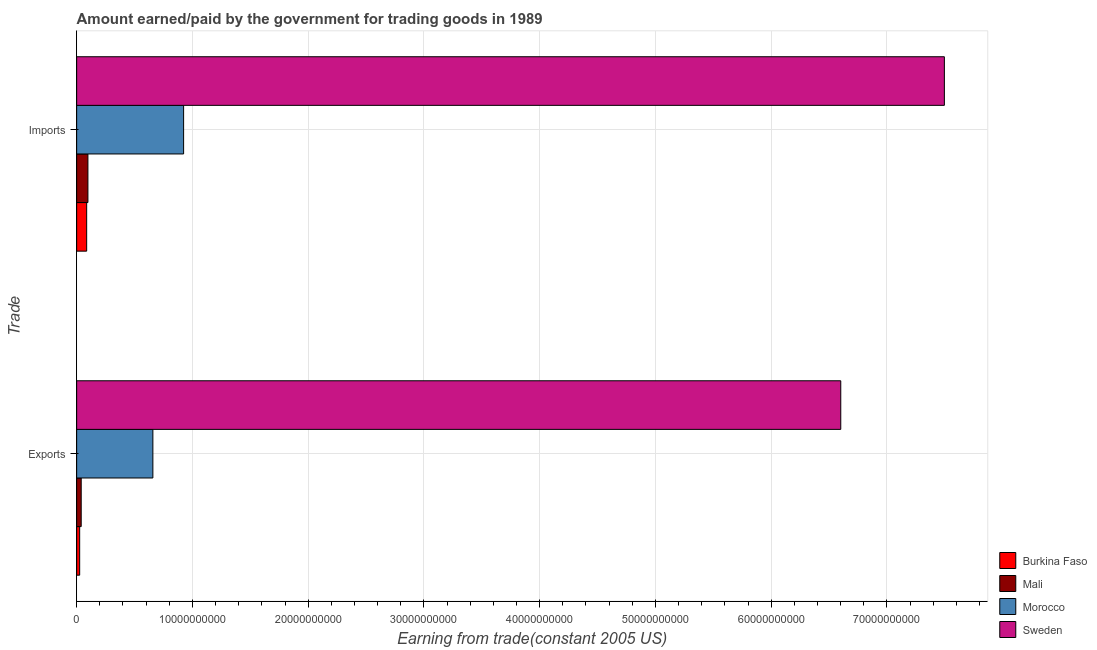How many different coloured bars are there?
Keep it short and to the point. 4. How many groups of bars are there?
Give a very brief answer. 2. Are the number of bars per tick equal to the number of legend labels?
Make the answer very short. Yes. Are the number of bars on each tick of the Y-axis equal?
Provide a short and direct response. Yes. How many bars are there on the 1st tick from the top?
Give a very brief answer. 4. How many bars are there on the 1st tick from the bottom?
Keep it short and to the point. 4. What is the label of the 2nd group of bars from the top?
Your answer should be compact. Exports. What is the amount paid for imports in Burkina Faso?
Make the answer very short. 8.65e+08. Across all countries, what is the maximum amount earned from exports?
Your response must be concise. 6.60e+1. Across all countries, what is the minimum amount paid for imports?
Offer a terse response. 8.65e+08. In which country was the amount paid for imports maximum?
Give a very brief answer. Sweden. In which country was the amount earned from exports minimum?
Give a very brief answer. Burkina Faso. What is the total amount paid for imports in the graph?
Make the answer very short. 8.60e+1. What is the difference between the amount earned from exports in Sweden and that in Morocco?
Ensure brevity in your answer.  5.94e+1. What is the difference between the amount earned from exports in Mali and the amount paid for imports in Morocco?
Make the answer very short. -8.85e+09. What is the average amount earned from exports per country?
Your answer should be very brief. 1.83e+1. What is the difference between the amount paid for imports and amount earned from exports in Morocco?
Provide a succinct answer. 2.66e+09. What is the ratio of the amount paid for imports in Mali to that in Morocco?
Make the answer very short. 0.11. In how many countries, is the amount paid for imports greater than the average amount paid for imports taken over all countries?
Your response must be concise. 1. What does the 2nd bar from the top in Exports represents?
Your response must be concise. Morocco. What does the 1st bar from the bottom in Exports represents?
Your response must be concise. Burkina Faso. How many bars are there?
Offer a terse response. 8. Are all the bars in the graph horizontal?
Offer a terse response. Yes. What is the difference between two consecutive major ticks on the X-axis?
Offer a terse response. 1.00e+1. Where does the legend appear in the graph?
Your answer should be very brief. Bottom right. How are the legend labels stacked?
Provide a short and direct response. Vertical. What is the title of the graph?
Provide a succinct answer. Amount earned/paid by the government for trading goods in 1989. Does "Vietnam" appear as one of the legend labels in the graph?
Make the answer very short. No. What is the label or title of the X-axis?
Provide a succinct answer. Earning from trade(constant 2005 US). What is the label or title of the Y-axis?
Make the answer very short. Trade. What is the Earning from trade(constant 2005 US) of Burkina Faso in Exports?
Provide a succinct answer. 2.60e+08. What is the Earning from trade(constant 2005 US) of Mali in Exports?
Your response must be concise. 3.92e+08. What is the Earning from trade(constant 2005 US) in Morocco in Exports?
Your answer should be very brief. 6.59e+09. What is the Earning from trade(constant 2005 US) in Sweden in Exports?
Offer a very short reply. 6.60e+1. What is the Earning from trade(constant 2005 US) of Burkina Faso in Imports?
Your response must be concise. 8.65e+08. What is the Earning from trade(constant 2005 US) of Mali in Imports?
Offer a terse response. 9.73e+08. What is the Earning from trade(constant 2005 US) of Morocco in Imports?
Give a very brief answer. 9.24e+09. What is the Earning from trade(constant 2005 US) in Sweden in Imports?
Offer a terse response. 7.50e+1. Across all Trade, what is the maximum Earning from trade(constant 2005 US) of Burkina Faso?
Offer a terse response. 8.65e+08. Across all Trade, what is the maximum Earning from trade(constant 2005 US) in Mali?
Your response must be concise. 9.73e+08. Across all Trade, what is the maximum Earning from trade(constant 2005 US) of Morocco?
Your answer should be very brief. 9.24e+09. Across all Trade, what is the maximum Earning from trade(constant 2005 US) of Sweden?
Your response must be concise. 7.50e+1. Across all Trade, what is the minimum Earning from trade(constant 2005 US) of Burkina Faso?
Offer a very short reply. 2.60e+08. Across all Trade, what is the minimum Earning from trade(constant 2005 US) of Mali?
Give a very brief answer. 3.92e+08. Across all Trade, what is the minimum Earning from trade(constant 2005 US) of Morocco?
Provide a short and direct response. 6.59e+09. Across all Trade, what is the minimum Earning from trade(constant 2005 US) in Sweden?
Your answer should be very brief. 6.60e+1. What is the total Earning from trade(constant 2005 US) of Burkina Faso in the graph?
Ensure brevity in your answer.  1.12e+09. What is the total Earning from trade(constant 2005 US) of Mali in the graph?
Provide a succinct answer. 1.36e+09. What is the total Earning from trade(constant 2005 US) in Morocco in the graph?
Your response must be concise. 1.58e+1. What is the total Earning from trade(constant 2005 US) of Sweden in the graph?
Give a very brief answer. 1.41e+11. What is the difference between the Earning from trade(constant 2005 US) in Burkina Faso in Exports and that in Imports?
Your answer should be very brief. -6.05e+08. What is the difference between the Earning from trade(constant 2005 US) of Mali in Exports and that in Imports?
Keep it short and to the point. -5.80e+08. What is the difference between the Earning from trade(constant 2005 US) in Morocco in Exports and that in Imports?
Provide a succinct answer. -2.66e+09. What is the difference between the Earning from trade(constant 2005 US) of Sweden in Exports and that in Imports?
Provide a succinct answer. -8.95e+09. What is the difference between the Earning from trade(constant 2005 US) of Burkina Faso in Exports and the Earning from trade(constant 2005 US) of Mali in Imports?
Your answer should be very brief. -7.13e+08. What is the difference between the Earning from trade(constant 2005 US) of Burkina Faso in Exports and the Earning from trade(constant 2005 US) of Morocco in Imports?
Give a very brief answer. -8.98e+09. What is the difference between the Earning from trade(constant 2005 US) in Burkina Faso in Exports and the Earning from trade(constant 2005 US) in Sweden in Imports?
Make the answer very short. -7.47e+1. What is the difference between the Earning from trade(constant 2005 US) in Mali in Exports and the Earning from trade(constant 2005 US) in Morocco in Imports?
Ensure brevity in your answer.  -8.85e+09. What is the difference between the Earning from trade(constant 2005 US) in Mali in Exports and the Earning from trade(constant 2005 US) in Sweden in Imports?
Offer a terse response. -7.46e+1. What is the difference between the Earning from trade(constant 2005 US) in Morocco in Exports and the Earning from trade(constant 2005 US) in Sweden in Imports?
Your answer should be compact. -6.84e+1. What is the average Earning from trade(constant 2005 US) of Burkina Faso per Trade?
Keep it short and to the point. 5.62e+08. What is the average Earning from trade(constant 2005 US) in Mali per Trade?
Offer a very short reply. 6.82e+08. What is the average Earning from trade(constant 2005 US) of Morocco per Trade?
Your response must be concise. 7.91e+09. What is the average Earning from trade(constant 2005 US) in Sweden per Trade?
Your answer should be very brief. 7.05e+1. What is the difference between the Earning from trade(constant 2005 US) in Burkina Faso and Earning from trade(constant 2005 US) in Mali in Exports?
Your answer should be very brief. -1.32e+08. What is the difference between the Earning from trade(constant 2005 US) in Burkina Faso and Earning from trade(constant 2005 US) in Morocco in Exports?
Make the answer very short. -6.33e+09. What is the difference between the Earning from trade(constant 2005 US) in Burkina Faso and Earning from trade(constant 2005 US) in Sweden in Exports?
Keep it short and to the point. -6.58e+1. What is the difference between the Earning from trade(constant 2005 US) in Mali and Earning from trade(constant 2005 US) in Morocco in Exports?
Keep it short and to the point. -6.19e+09. What is the difference between the Earning from trade(constant 2005 US) in Mali and Earning from trade(constant 2005 US) in Sweden in Exports?
Your answer should be very brief. -6.56e+1. What is the difference between the Earning from trade(constant 2005 US) of Morocco and Earning from trade(constant 2005 US) of Sweden in Exports?
Offer a very short reply. -5.94e+1. What is the difference between the Earning from trade(constant 2005 US) in Burkina Faso and Earning from trade(constant 2005 US) in Mali in Imports?
Your answer should be compact. -1.08e+08. What is the difference between the Earning from trade(constant 2005 US) in Burkina Faso and Earning from trade(constant 2005 US) in Morocco in Imports?
Your response must be concise. -8.38e+09. What is the difference between the Earning from trade(constant 2005 US) of Burkina Faso and Earning from trade(constant 2005 US) of Sweden in Imports?
Offer a very short reply. -7.41e+1. What is the difference between the Earning from trade(constant 2005 US) in Mali and Earning from trade(constant 2005 US) in Morocco in Imports?
Provide a short and direct response. -8.27e+09. What is the difference between the Earning from trade(constant 2005 US) in Mali and Earning from trade(constant 2005 US) in Sweden in Imports?
Your response must be concise. -7.40e+1. What is the difference between the Earning from trade(constant 2005 US) of Morocco and Earning from trade(constant 2005 US) of Sweden in Imports?
Your response must be concise. -6.57e+1. What is the ratio of the Earning from trade(constant 2005 US) in Burkina Faso in Exports to that in Imports?
Your answer should be compact. 0.3. What is the ratio of the Earning from trade(constant 2005 US) of Mali in Exports to that in Imports?
Provide a succinct answer. 0.4. What is the ratio of the Earning from trade(constant 2005 US) in Morocco in Exports to that in Imports?
Your answer should be compact. 0.71. What is the ratio of the Earning from trade(constant 2005 US) of Sweden in Exports to that in Imports?
Give a very brief answer. 0.88. What is the difference between the highest and the second highest Earning from trade(constant 2005 US) of Burkina Faso?
Keep it short and to the point. 6.05e+08. What is the difference between the highest and the second highest Earning from trade(constant 2005 US) of Mali?
Your answer should be very brief. 5.80e+08. What is the difference between the highest and the second highest Earning from trade(constant 2005 US) in Morocco?
Offer a terse response. 2.66e+09. What is the difference between the highest and the second highest Earning from trade(constant 2005 US) of Sweden?
Give a very brief answer. 8.95e+09. What is the difference between the highest and the lowest Earning from trade(constant 2005 US) in Burkina Faso?
Offer a very short reply. 6.05e+08. What is the difference between the highest and the lowest Earning from trade(constant 2005 US) of Mali?
Your answer should be compact. 5.80e+08. What is the difference between the highest and the lowest Earning from trade(constant 2005 US) in Morocco?
Make the answer very short. 2.66e+09. What is the difference between the highest and the lowest Earning from trade(constant 2005 US) in Sweden?
Ensure brevity in your answer.  8.95e+09. 